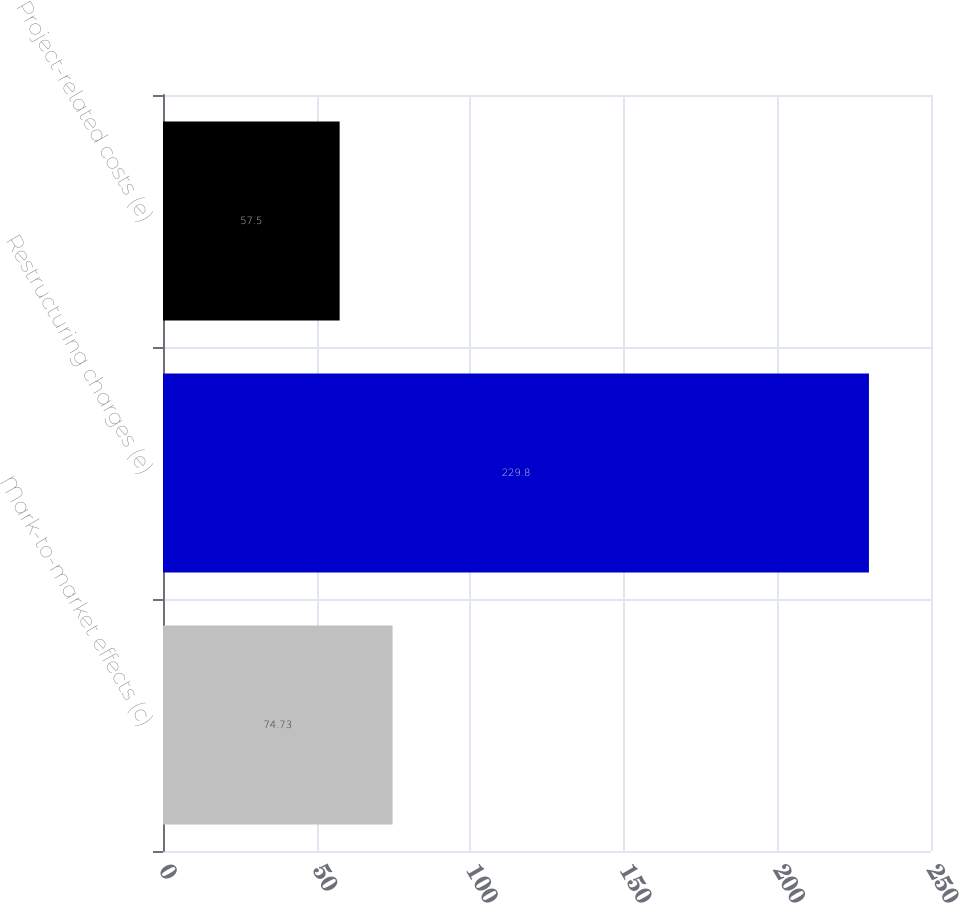Convert chart to OTSL. <chart><loc_0><loc_0><loc_500><loc_500><bar_chart><fcel>Mark-to-market effects (c)<fcel>Restructuring charges (e)<fcel>Project-related costs (e)<nl><fcel>74.73<fcel>229.8<fcel>57.5<nl></chart> 